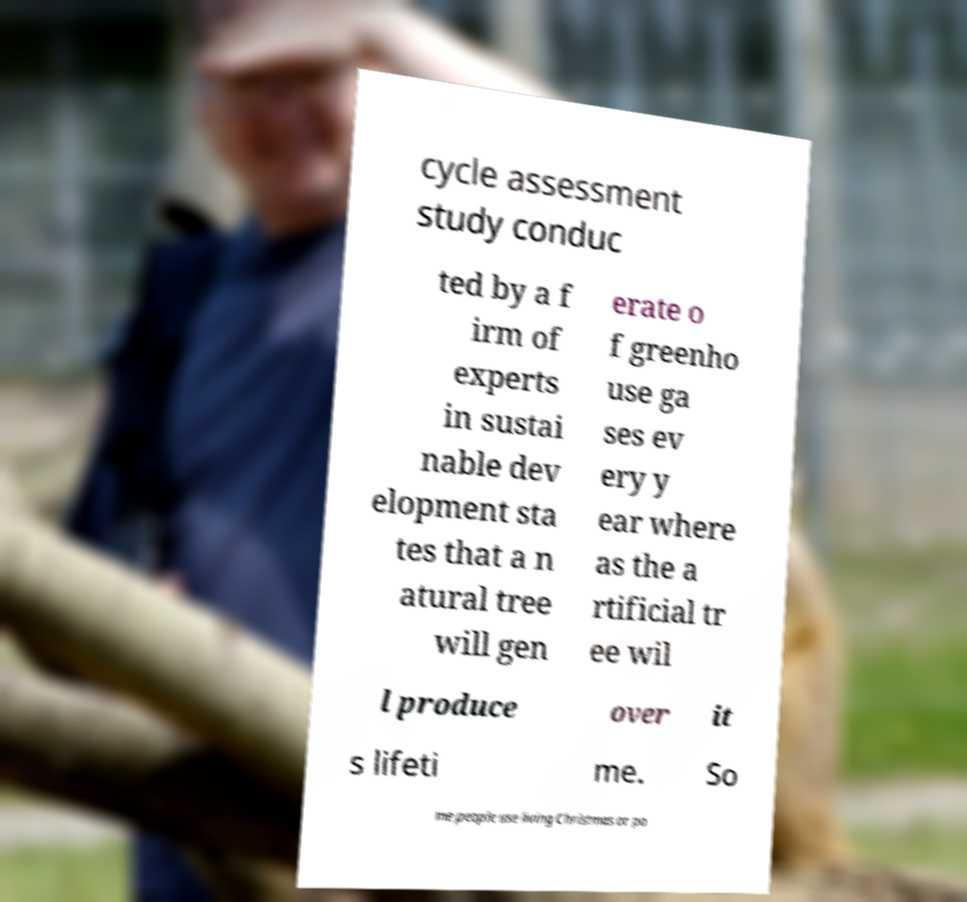Can you read and provide the text displayed in the image?This photo seems to have some interesting text. Can you extract and type it out for me? cycle assessment study conduc ted by a f irm of experts in sustai nable dev elopment sta tes that a n atural tree will gen erate o f greenho use ga ses ev ery y ear where as the a rtificial tr ee wil l produce over it s lifeti me. So me people use living Christmas or po 